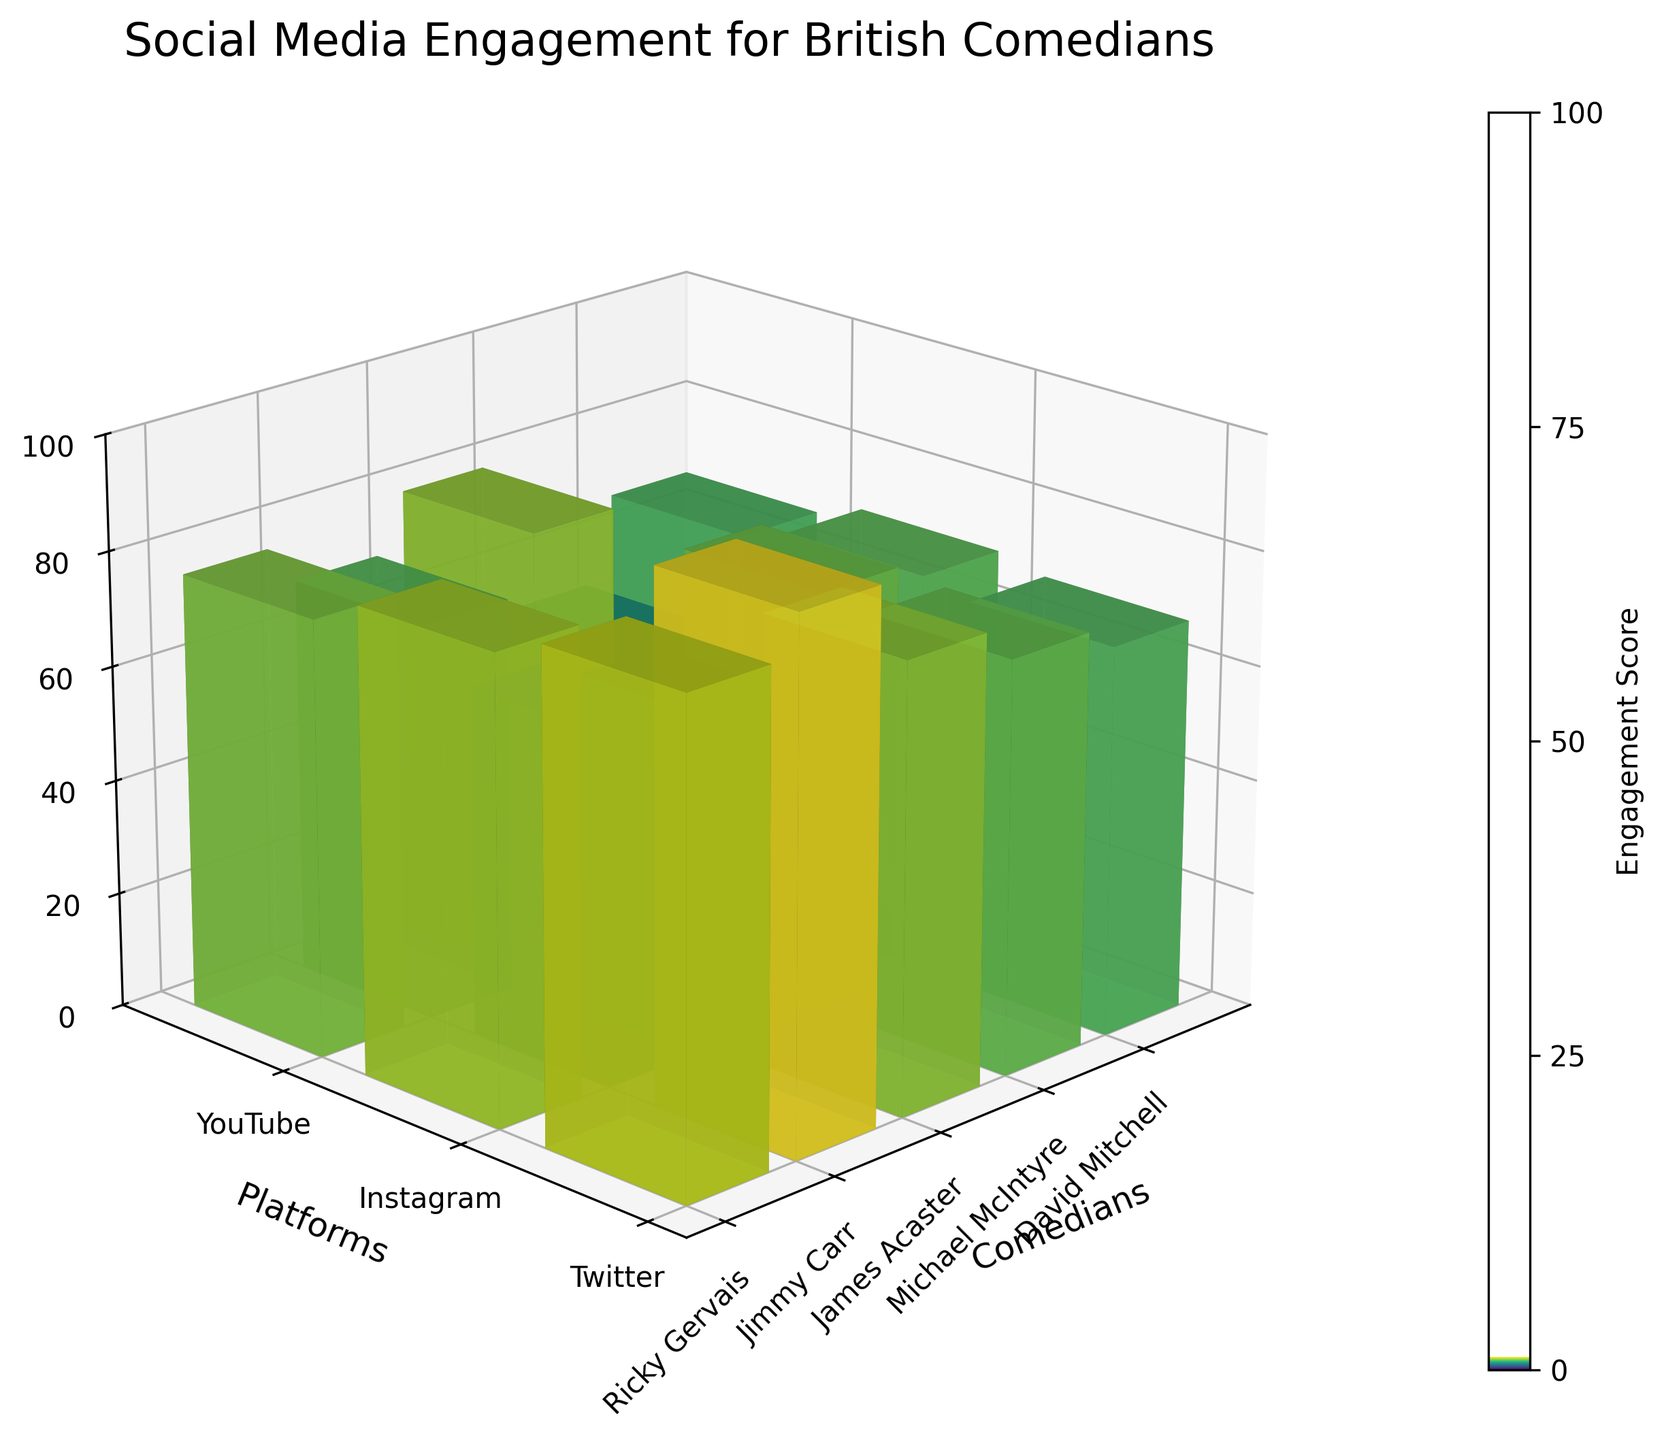What is the highest engagement score on Instagram? To find the highest engagement score on Instagram, look at the bars representing engagement scores specifically for Instagram across all comedians. The tallest bar among these corresponds to the highest score.
Answer: 92 Which comedian has the lowest engagement score on YouTube? To determine the comedian with the lowest engagement score on YouTube, examine the shortest bar corresponding to YouTube. This bar represents the lowest score on that platform.
Answer: David Mitchell What is the average engagement score for Ricky Gervais across all platforms? To find the average engagement score for Ricky Gervais, sum the engagement scores for Ricky across all platforms (Twitter, Instagram, YouTube) and divide by the number of platforms. The scores are 85, 92, and 78, respectively. The sum is 85 + 92 + 78 = 255, and the average is 255 / 3 = 85.
Answer: 85 Between Jimmy Carr and Michael McIntyre, who has the higher total engagement score on all platforms combined? Calculate the total engagement score for each comedian across all platforms (Twitter, Instagram, YouTube). Jimmy Carr: 72 + 68 + 81 = 221; Michael McIntyre: 70 + 76 + 69 = 215. Compare the sums to determine the higher total score.
Answer: Jimmy Carr Which platform has the highest engagement score for James Acaster? Look at the bars representing James Acaster's engagement scores across platforms (Twitter, Instagram, YouTube) and find the tallest bar to identify the highest score.
Answer: YouTube Who has the highest engagement score on Twitter? Examine the bars representing engagement scores across all comedians for Twitter. Identify the tallest bar to find which comedian has the highest score on this platform.
Answer: Ricky Gervais Compare the engagement score of David Mitchell on Instagram versus that on Twitter. Which one is higher? Look at David Mitchell's engagement scores on Instagram and Twitter. The heights of the bars corresponding to each platform indicate which one is higher.
Answer: Twitter What is the overall range of engagement scores shown in the plot? To find the range of engagement scores, determine the highest and lowest scores in the dataset. The highest score is 92 (Ricky Gervais on Instagram), and the lowest score is 52 (David Mitchell on Instagram). Subtract the lowest from the highest: 92 - 52.
Answer: 40 How does Ricky Gervais' engagement score on YouTube compare to Jimmy Carr’s on the same platform? Compare the height of the bar representing Ricky Gervais' engagement score on YouTube with the height of the bar for Jimmy Carr on YouTube.
Answer: Jimmy Carr's is higher 